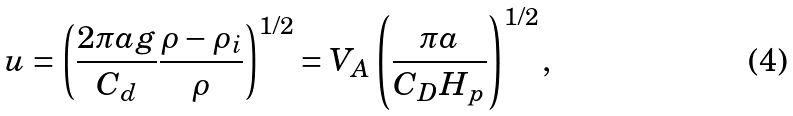Convert formula to latex. <formula><loc_0><loc_0><loc_500><loc_500>u = \left ( \frac { 2 \pi a g } { C _ { d } } \frac { \rho - \rho _ { i } } { \rho } \right ) ^ { 1 / 2 } = V _ { A } \left ( \frac { \pi a } { C _ { D } H _ { p } } \right ) ^ { 1 / 2 } ,</formula> 